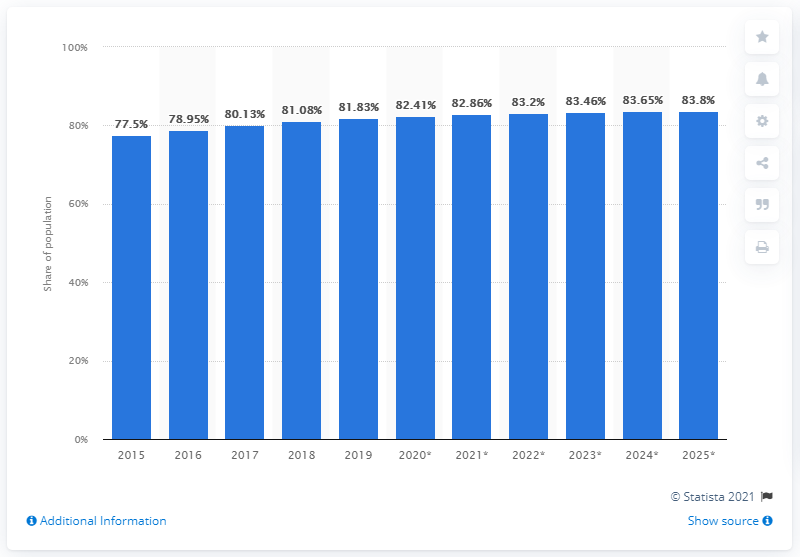Highlight a few significant elements in this photo. By 2025, it is projected that the use of the internet in Singapore will increase to 83.8%. 